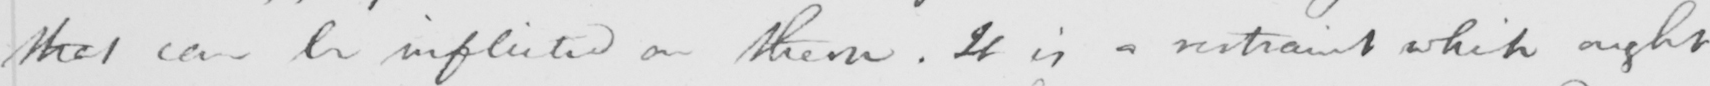Please provide the text content of this handwritten line. that can be inflicted on them . It is a restraint which ought 